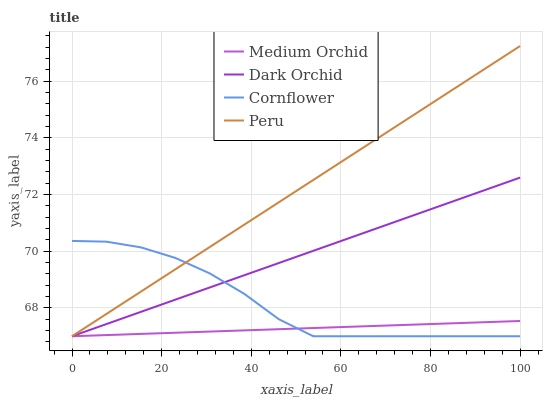Does Peru have the minimum area under the curve?
Answer yes or no. No. Does Medium Orchid have the maximum area under the curve?
Answer yes or no. No. Is Medium Orchid the smoothest?
Answer yes or no. No. Is Medium Orchid the roughest?
Answer yes or no. No. Does Medium Orchid have the highest value?
Answer yes or no. No. 